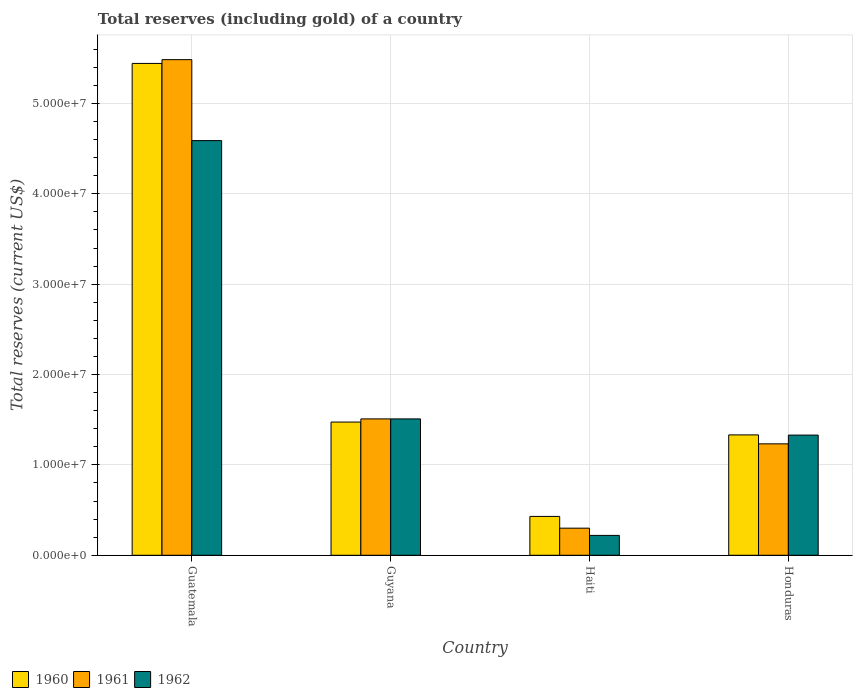Are the number of bars per tick equal to the number of legend labels?
Provide a succinct answer. Yes. Are the number of bars on each tick of the X-axis equal?
Offer a very short reply. Yes. What is the label of the 2nd group of bars from the left?
Offer a very short reply. Guyana. In how many cases, is the number of bars for a given country not equal to the number of legend labels?
Offer a terse response. 0. What is the total reserves (including gold) in 1960 in Guatemala?
Provide a short and direct response. 5.44e+07. Across all countries, what is the maximum total reserves (including gold) in 1960?
Ensure brevity in your answer.  5.44e+07. Across all countries, what is the minimum total reserves (including gold) in 1961?
Your answer should be very brief. 3.00e+06. In which country was the total reserves (including gold) in 1960 maximum?
Ensure brevity in your answer.  Guatemala. In which country was the total reserves (including gold) in 1962 minimum?
Give a very brief answer. Haiti. What is the total total reserves (including gold) in 1960 in the graph?
Provide a short and direct response. 8.68e+07. What is the difference between the total reserves (including gold) in 1962 in Guyana and that in Haiti?
Keep it short and to the point. 1.29e+07. What is the difference between the total reserves (including gold) in 1961 in Haiti and the total reserves (including gold) in 1962 in Guyana?
Provide a succinct answer. -1.21e+07. What is the average total reserves (including gold) in 1961 per country?
Ensure brevity in your answer.  2.13e+07. What is the difference between the total reserves (including gold) of/in 1960 and total reserves (including gold) of/in 1962 in Guyana?
Your answer should be very brief. -3.50e+05. What is the ratio of the total reserves (including gold) in 1962 in Guatemala to that in Haiti?
Your answer should be compact. 20.86. Is the total reserves (including gold) in 1960 in Guatemala less than that in Honduras?
Your answer should be very brief. No. Is the difference between the total reserves (including gold) in 1960 in Guyana and Haiti greater than the difference between the total reserves (including gold) in 1962 in Guyana and Haiti?
Your answer should be compact. No. What is the difference between the highest and the second highest total reserves (including gold) in 1960?
Provide a short and direct response. 1.42e+06. What is the difference between the highest and the lowest total reserves (including gold) in 1962?
Offer a very short reply. 4.37e+07. What does the 2nd bar from the right in Haiti represents?
Offer a very short reply. 1961. Are all the bars in the graph horizontal?
Provide a short and direct response. No. How many countries are there in the graph?
Make the answer very short. 4. Are the values on the major ticks of Y-axis written in scientific E-notation?
Keep it short and to the point. Yes. Where does the legend appear in the graph?
Your answer should be compact. Bottom left. How many legend labels are there?
Make the answer very short. 3. What is the title of the graph?
Provide a short and direct response. Total reserves (including gold) of a country. What is the label or title of the Y-axis?
Provide a short and direct response. Total reserves (current US$). What is the Total reserves (current US$) of 1960 in Guatemala?
Give a very brief answer. 5.44e+07. What is the Total reserves (current US$) of 1961 in Guatemala?
Provide a succinct answer. 5.48e+07. What is the Total reserves (current US$) in 1962 in Guatemala?
Offer a terse response. 4.59e+07. What is the Total reserves (current US$) of 1960 in Guyana?
Offer a very short reply. 1.47e+07. What is the Total reserves (current US$) of 1961 in Guyana?
Ensure brevity in your answer.  1.51e+07. What is the Total reserves (current US$) in 1962 in Guyana?
Your answer should be compact. 1.51e+07. What is the Total reserves (current US$) in 1960 in Haiti?
Keep it short and to the point. 4.30e+06. What is the Total reserves (current US$) of 1961 in Haiti?
Offer a terse response. 3.00e+06. What is the Total reserves (current US$) of 1962 in Haiti?
Offer a very short reply. 2.20e+06. What is the Total reserves (current US$) of 1960 in Honduras?
Provide a succinct answer. 1.33e+07. What is the Total reserves (current US$) in 1961 in Honduras?
Provide a succinct answer. 1.23e+07. What is the Total reserves (current US$) of 1962 in Honduras?
Offer a terse response. 1.33e+07. Across all countries, what is the maximum Total reserves (current US$) in 1960?
Offer a terse response. 5.44e+07. Across all countries, what is the maximum Total reserves (current US$) of 1961?
Give a very brief answer. 5.48e+07. Across all countries, what is the maximum Total reserves (current US$) in 1962?
Offer a terse response. 4.59e+07. Across all countries, what is the minimum Total reserves (current US$) of 1960?
Your response must be concise. 4.30e+06. Across all countries, what is the minimum Total reserves (current US$) of 1961?
Ensure brevity in your answer.  3.00e+06. Across all countries, what is the minimum Total reserves (current US$) in 1962?
Offer a terse response. 2.20e+06. What is the total Total reserves (current US$) of 1960 in the graph?
Your response must be concise. 8.68e+07. What is the total Total reserves (current US$) of 1961 in the graph?
Your answer should be very brief. 8.53e+07. What is the total Total reserves (current US$) in 1962 in the graph?
Your answer should be compact. 7.65e+07. What is the difference between the Total reserves (current US$) of 1960 in Guatemala and that in Guyana?
Give a very brief answer. 3.97e+07. What is the difference between the Total reserves (current US$) of 1961 in Guatemala and that in Guyana?
Your response must be concise. 3.98e+07. What is the difference between the Total reserves (current US$) in 1962 in Guatemala and that in Guyana?
Offer a very short reply. 3.08e+07. What is the difference between the Total reserves (current US$) of 1960 in Guatemala and that in Haiti?
Offer a terse response. 5.01e+07. What is the difference between the Total reserves (current US$) in 1961 in Guatemala and that in Haiti?
Offer a very short reply. 5.18e+07. What is the difference between the Total reserves (current US$) of 1962 in Guatemala and that in Haiti?
Provide a succinct answer. 4.37e+07. What is the difference between the Total reserves (current US$) in 1960 in Guatemala and that in Honduras?
Your answer should be compact. 4.11e+07. What is the difference between the Total reserves (current US$) in 1961 in Guatemala and that in Honduras?
Offer a terse response. 4.25e+07. What is the difference between the Total reserves (current US$) in 1962 in Guatemala and that in Honduras?
Offer a very short reply. 3.26e+07. What is the difference between the Total reserves (current US$) of 1960 in Guyana and that in Haiti?
Ensure brevity in your answer.  1.04e+07. What is the difference between the Total reserves (current US$) of 1961 in Guyana and that in Haiti?
Offer a terse response. 1.21e+07. What is the difference between the Total reserves (current US$) in 1962 in Guyana and that in Haiti?
Provide a succinct answer. 1.29e+07. What is the difference between the Total reserves (current US$) in 1960 in Guyana and that in Honduras?
Provide a succinct answer. 1.42e+06. What is the difference between the Total reserves (current US$) in 1961 in Guyana and that in Honduras?
Make the answer very short. 2.76e+06. What is the difference between the Total reserves (current US$) of 1962 in Guyana and that in Honduras?
Your response must be concise. 1.79e+06. What is the difference between the Total reserves (current US$) of 1960 in Haiti and that in Honduras?
Offer a very short reply. -9.02e+06. What is the difference between the Total reserves (current US$) of 1961 in Haiti and that in Honduras?
Provide a succinct answer. -9.33e+06. What is the difference between the Total reserves (current US$) of 1962 in Haiti and that in Honduras?
Your answer should be very brief. -1.11e+07. What is the difference between the Total reserves (current US$) in 1960 in Guatemala and the Total reserves (current US$) in 1961 in Guyana?
Offer a terse response. 3.93e+07. What is the difference between the Total reserves (current US$) of 1960 in Guatemala and the Total reserves (current US$) of 1962 in Guyana?
Provide a succinct answer. 3.93e+07. What is the difference between the Total reserves (current US$) in 1961 in Guatemala and the Total reserves (current US$) in 1962 in Guyana?
Provide a succinct answer. 3.98e+07. What is the difference between the Total reserves (current US$) of 1960 in Guatemala and the Total reserves (current US$) of 1961 in Haiti?
Keep it short and to the point. 5.14e+07. What is the difference between the Total reserves (current US$) in 1960 in Guatemala and the Total reserves (current US$) in 1962 in Haiti?
Offer a very short reply. 5.22e+07. What is the difference between the Total reserves (current US$) in 1961 in Guatemala and the Total reserves (current US$) in 1962 in Haiti?
Give a very brief answer. 5.26e+07. What is the difference between the Total reserves (current US$) of 1960 in Guatemala and the Total reserves (current US$) of 1961 in Honduras?
Your response must be concise. 4.21e+07. What is the difference between the Total reserves (current US$) in 1960 in Guatemala and the Total reserves (current US$) in 1962 in Honduras?
Provide a succinct answer. 4.11e+07. What is the difference between the Total reserves (current US$) of 1961 in Guatemala and the Total reserves (current US$) of 1962 in Honduras?
Ensure brevity in your answer.  4.15e+07. What is the difference between the Total reserves (current US$) in 1960 in Guyana and the Total reserves (current US$) in 1961 in Haiti?
Your answer should be compact. 1.17e+07. What is the difference between the Total reserves (current US$) in 1960 in Guyana and the Total reserves (current US$) in 1962 in Haiti?
Keep it short and to the point. 1.25e+07. What is the difference between the Total reserves (current US$) of 1961 in Guyana and the Total reserves (current US$) of 1962 in Haiti?
Offer a very short reply. 1.29e+07. What is the difference between the Total reserves (current US$) in 1960 in Guyana and the Total reserves (current US$) in 1961 in Honduras?
Keep it short and to the point. 2.41e+06. What is the difference between the Total reserves (current US$) in 1960 in Guyana and the Total reserves (current US$) in 1962 in Honduras?
Your answer should be compact. 1.44e+06. What is the difference between the Total reserves (current US$) of 1961 in Guyana and the Total reserves (current US$) of 1962 in Honduras?
Keep it short and to the point. 1.79e+06. What is the difference between the Total reserves (current US$) of 1960 in Haiti and the Total reserves (current US$) of 1961 in Honduras?
Your answer should be compact. -8.03e+06. What is the difference between the Total reserves (current US$) of 1960 in Haiti and the Total reserves (current US$) of 1962 in Honduras?
Provide a succinct answer. -9.00e+06. What is the difference between the Total reserves (current US$) of 1961 in Haiti and the Total reserves (current US$) of 1962 in Honduras?
Make the answer very short. -1.03e+07. What is the average Total reserves (current US$) in 1960 per country?
Ensure brevity in your answer.  2.17e+07. What is the average Total reserves (current US$) in 1961 per country?
Keep it short and to the point. 2.13e+07. What is the average Total reserves (current US$) of 1962 per country?
Make the answer very short. 1.91e+07. What is the difference between the Total reserves (current US$) in 1960 and Total reserves (current US$) in 1961 in Guatemala?
Make the answer very short. -4.18e+05. What is the difference between the Total reserves (current US$) in 1960 and Total reserves (current US$) in 1962 in Guatemala?
Make the answer very short. 8.54e+06. What is the difference between the Total reserves (current US$) of 1961 and Total reserves (current US$) of 1962 in Guatemala?
Your answer should be very brief. 8.96e+06. What is the difference between the Total reserves (current US$) of 1960 and Total reserves (current US$) of 1961 in Guyana?
Provide a short and direct response. -3.50e+05. What is the difference between the Total reserves (current US$) in 1960 and Total reserves (current US$) in 1962 in Guyana?
Ensure brevity in your answer.  -3.50e+05. What is the difference between the Total reserves (current US$) in 1960 and Total reserves (current US$) in 1961 in Haiti?
Your answer should be compact. 1.30e+06. What is the difference between the Total reserves (current US$) in 1960 and Total reserves (current US$) in 1962 in Haiti?
Provide a succinct answer. 2.10e+06. What is the difference between the Total reserves (current US$) in 1960 and Total reserves (current US$) in 1961 in Honduras?
Make the answer very short. 9.91e+05. What is the difference between the Total reserves (current US$) in 1960 and Total reserves (current US$) in 1962 in Honduras?
Give a very brief answer. 2.16e+04. What is the difference between the Total reserves (current US$) of 1961 and Total reserves (current US$) of 1962 in Honduras?
Keep it short and to the point. -9.70e+05. What is the ratio of the Total reserves (current US$) of 1960 in Guatemala to that in Guyana?
Your answer should be compact. 3.69. What is the ratio of the Total reserves (current US$) in 1961 in Guatemala to that in Guyana?
Ensure brevity in your answer.  3.63. What is the ratio of the Total reserves (current US$) of 1962 in Guatemala to that in Guyana?
Make the answer very short. 3.04. What is the ratio of the Total reserves (current US$) of 1960 in Guatemala to that in Haiti?
Your answer should be very brief. 12.66. What is the ratio of the Total reserves (current US$) in 1961 in Guatemala to that in Haiti?
Provide a short and direct response. 18.28. What is the ratio of the Total reserves (current US$) of 1962 in Guatemala to that in Haiti?
Provide a short and direct response. 20.86. What is the ratio of the Total reserves (current US$) of 1960 in Guatemala to that in Honduras?
Give a very brief answer. 4.09. What is the ratio of the Total reserves (current US$) of 1961 in Guatemala to that in Honduras?
Provide a short and direct response. 4.45. What is the ratio of the Total reserves (current US$) in 1962 in Guatemala to that in Honduras?
Offer a terse response. 3.45. What is the ratio of the Total reserves (current US$) in 1960 in Guyana to that in Haiti?
Your answer should be very brief. 3.43. What is the ratio of the Total reserves (current US$) in 1961 in Guyana to that in Haiti?
Your response must be concise. 5.03. What is the ratio of the Total reserves (current US$) in 1962 in Guyana to that in Haiti?
Your answer should be compact. 6.86. What is the ratio of the Total reserves (current US$) of 1960 in Guyana to that in Honduras?
Make the answer very short. 1.11. What is the ratio of the Total reserves (current US$) of 1961 in Guyana to that in Honduras?
Provide a succinct answer. 1.22. What is the ratio of the Total reserves (current US$) in 1962 in Guyana to that in Honduras?
Offer a terse response. 1.13. What is the ratio of the Total reserves (current US$) in 1960 in Haiti to that in Honduras?
Your response must be concise. 0.32. What is the ratio of the Total reserves (current US$) of 1961 in Haiti to that in Honduras?
Make the answer very short. 0.24. What is the ratio of the Total reserves (current US$) in 1962 in Haiti to that in Honduras?
Keep it short and to the point. 0.17. What is the difference between the highest and the second highest Total reserves (current US$) in 1960?
Your answer should be very brief. 3.97e+07. What is the difference between the highest and the second highest Total reserves (current US$) in 1961?
Provide a short and direct response. 3.98e+07. What is the difference between the highest and the second highest Total reserves (current US$) in 1962?
Your answer should be very brief. 3.08e+07. What is the difference between the highest and the lowest Total reserves (current US$) of 1960?
Keep it short and to the point. 5.01e+07. What is the difference between the highest and the lowest Total reserves (current US$) in 1961?
Your answer should be very brief. 5.18e+07. What is the difference between the highest and the lowest Total reserves (current US$) in 1962?
Offer a terse response. 4.37e+07. 